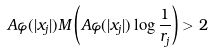Convert formula to latex. <formula><loc_0><loc_0><loc_500><loc_500>A \varphi ( | x _ { j } | ) M \left ( A \varphi ( | x _ { j } | ) \log \frac { 1 } { r _ { j } } \right ) > 2</formula> 